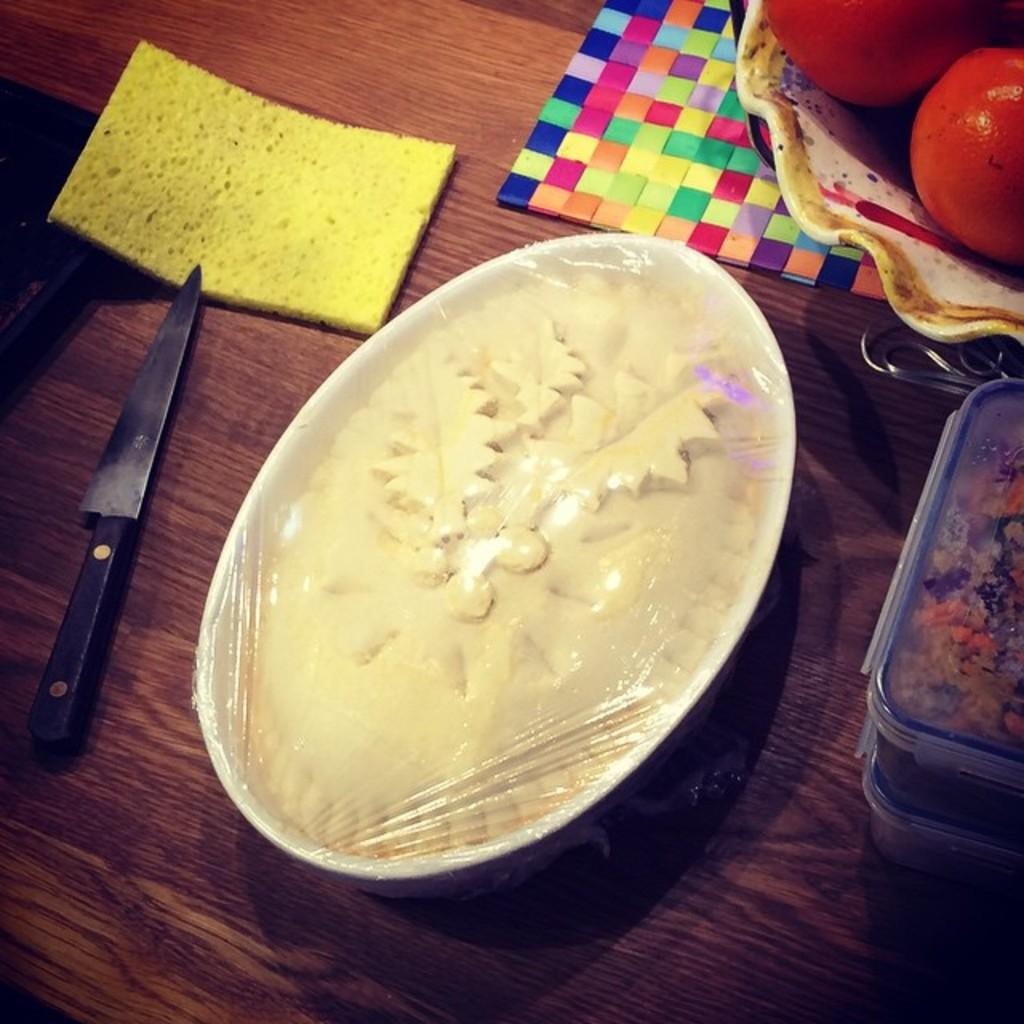What type of items can be seen in the image? There are kitchen tools, fruits, and food items in the image. How are the fruits and food items stored in the image? The fruits are in a bowl, and there are food items in a bowl and a box. Where might these items be placed in the image? The items may be placed on a table. What type of location might the image have been taken in? The image might have been taken in a room. How many tomatoes are visible on the door in the image? There are no tomatoes or doors present in the image. 